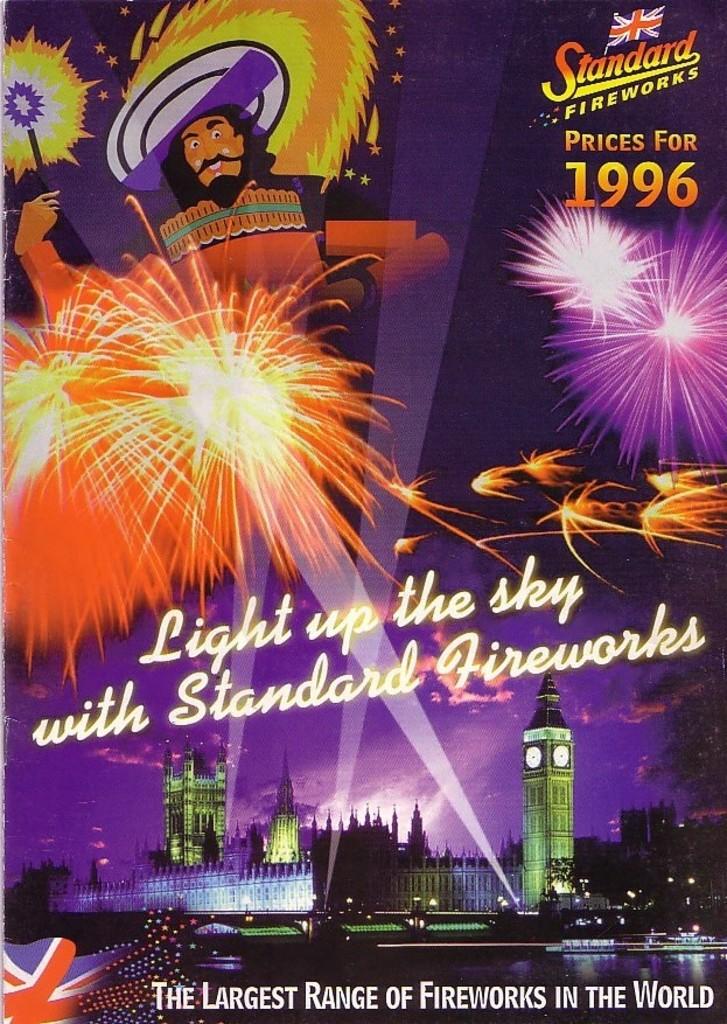What year are the prices for?
Offer a terse response. 1996. It says the what range of fireworks?
Provide a short and direct response. Largest. 